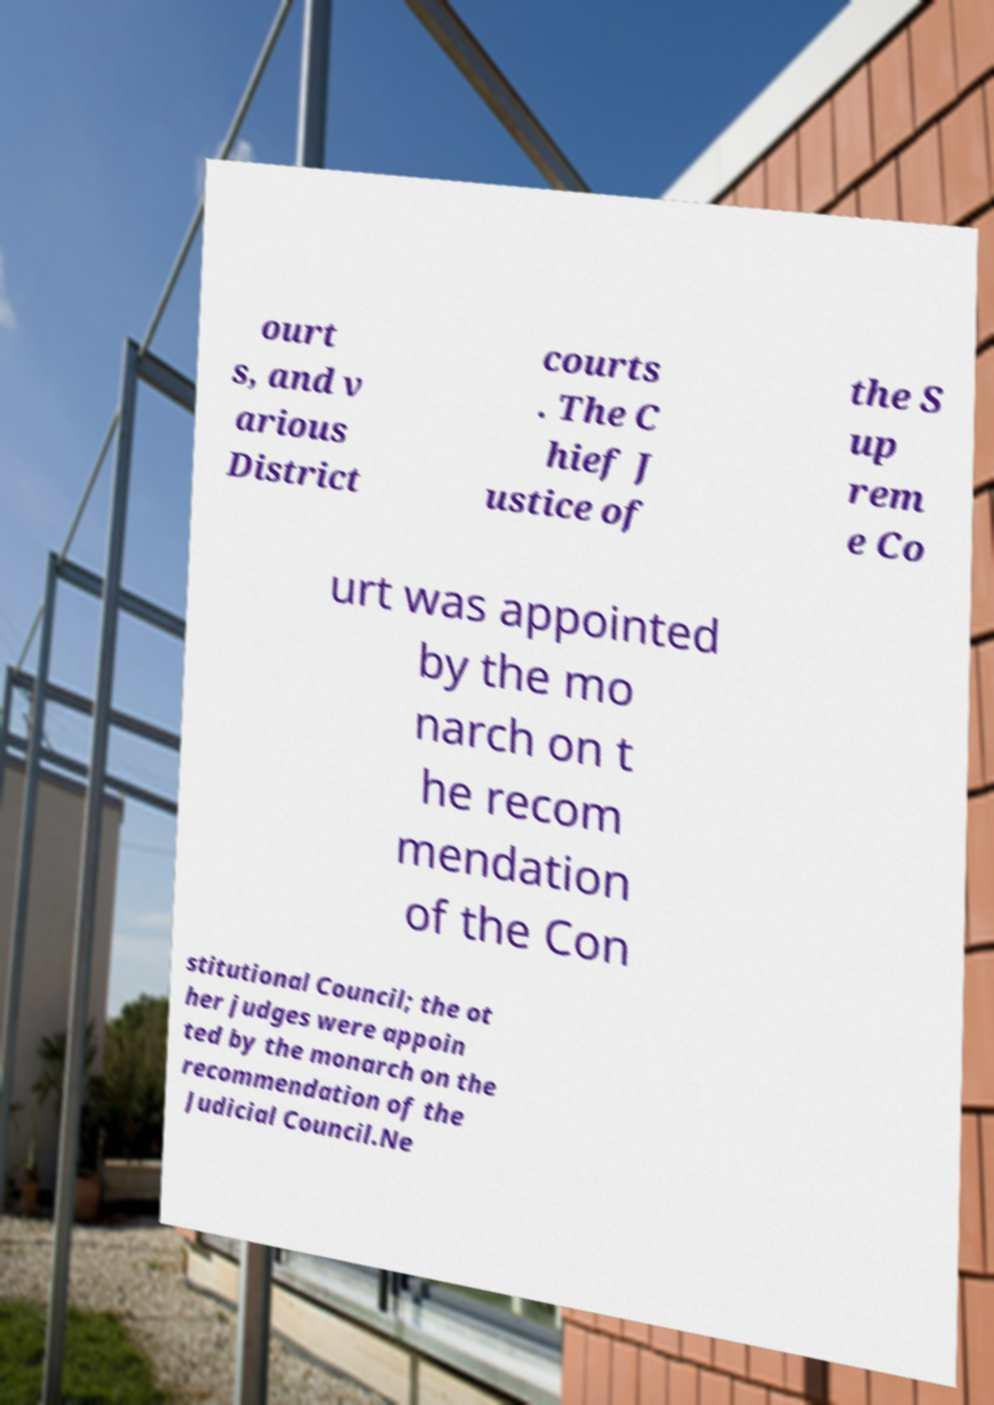For documentation purposes, I need the text within this image transcribed. Could you provide that? ourt s, and v arious District courts . The C hief J ustice of the S up rem e Co urt was appointed by the mo narch on t he recom mendation of the Con stitutional Council; the ot her judges were appoin ted by the monarch on the recommendation of the Judicial Council.Ne 